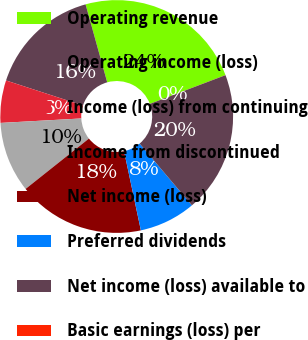Convert chart to OTSL. <chart><loc_0><loc_0><loc_500><loc_500><pie_chart><fcel>Operating revenue<fcel>Operating income (loss)<fcel>Income (loss) from continuing<fcel>Income from discontinued<fcel>Net income (loss)<fcel>Preferred dividends<fcel>Net income (loss) available to<fcel>Basic earnings (loss) per<nl><fcel>23.52%<fcel>15.68%<fcel>5.89%<fcel>9.81%<fcel>17.64%<fcel>7.85%<fcel>19.6%<fcel>0.01%<nl></chart> 